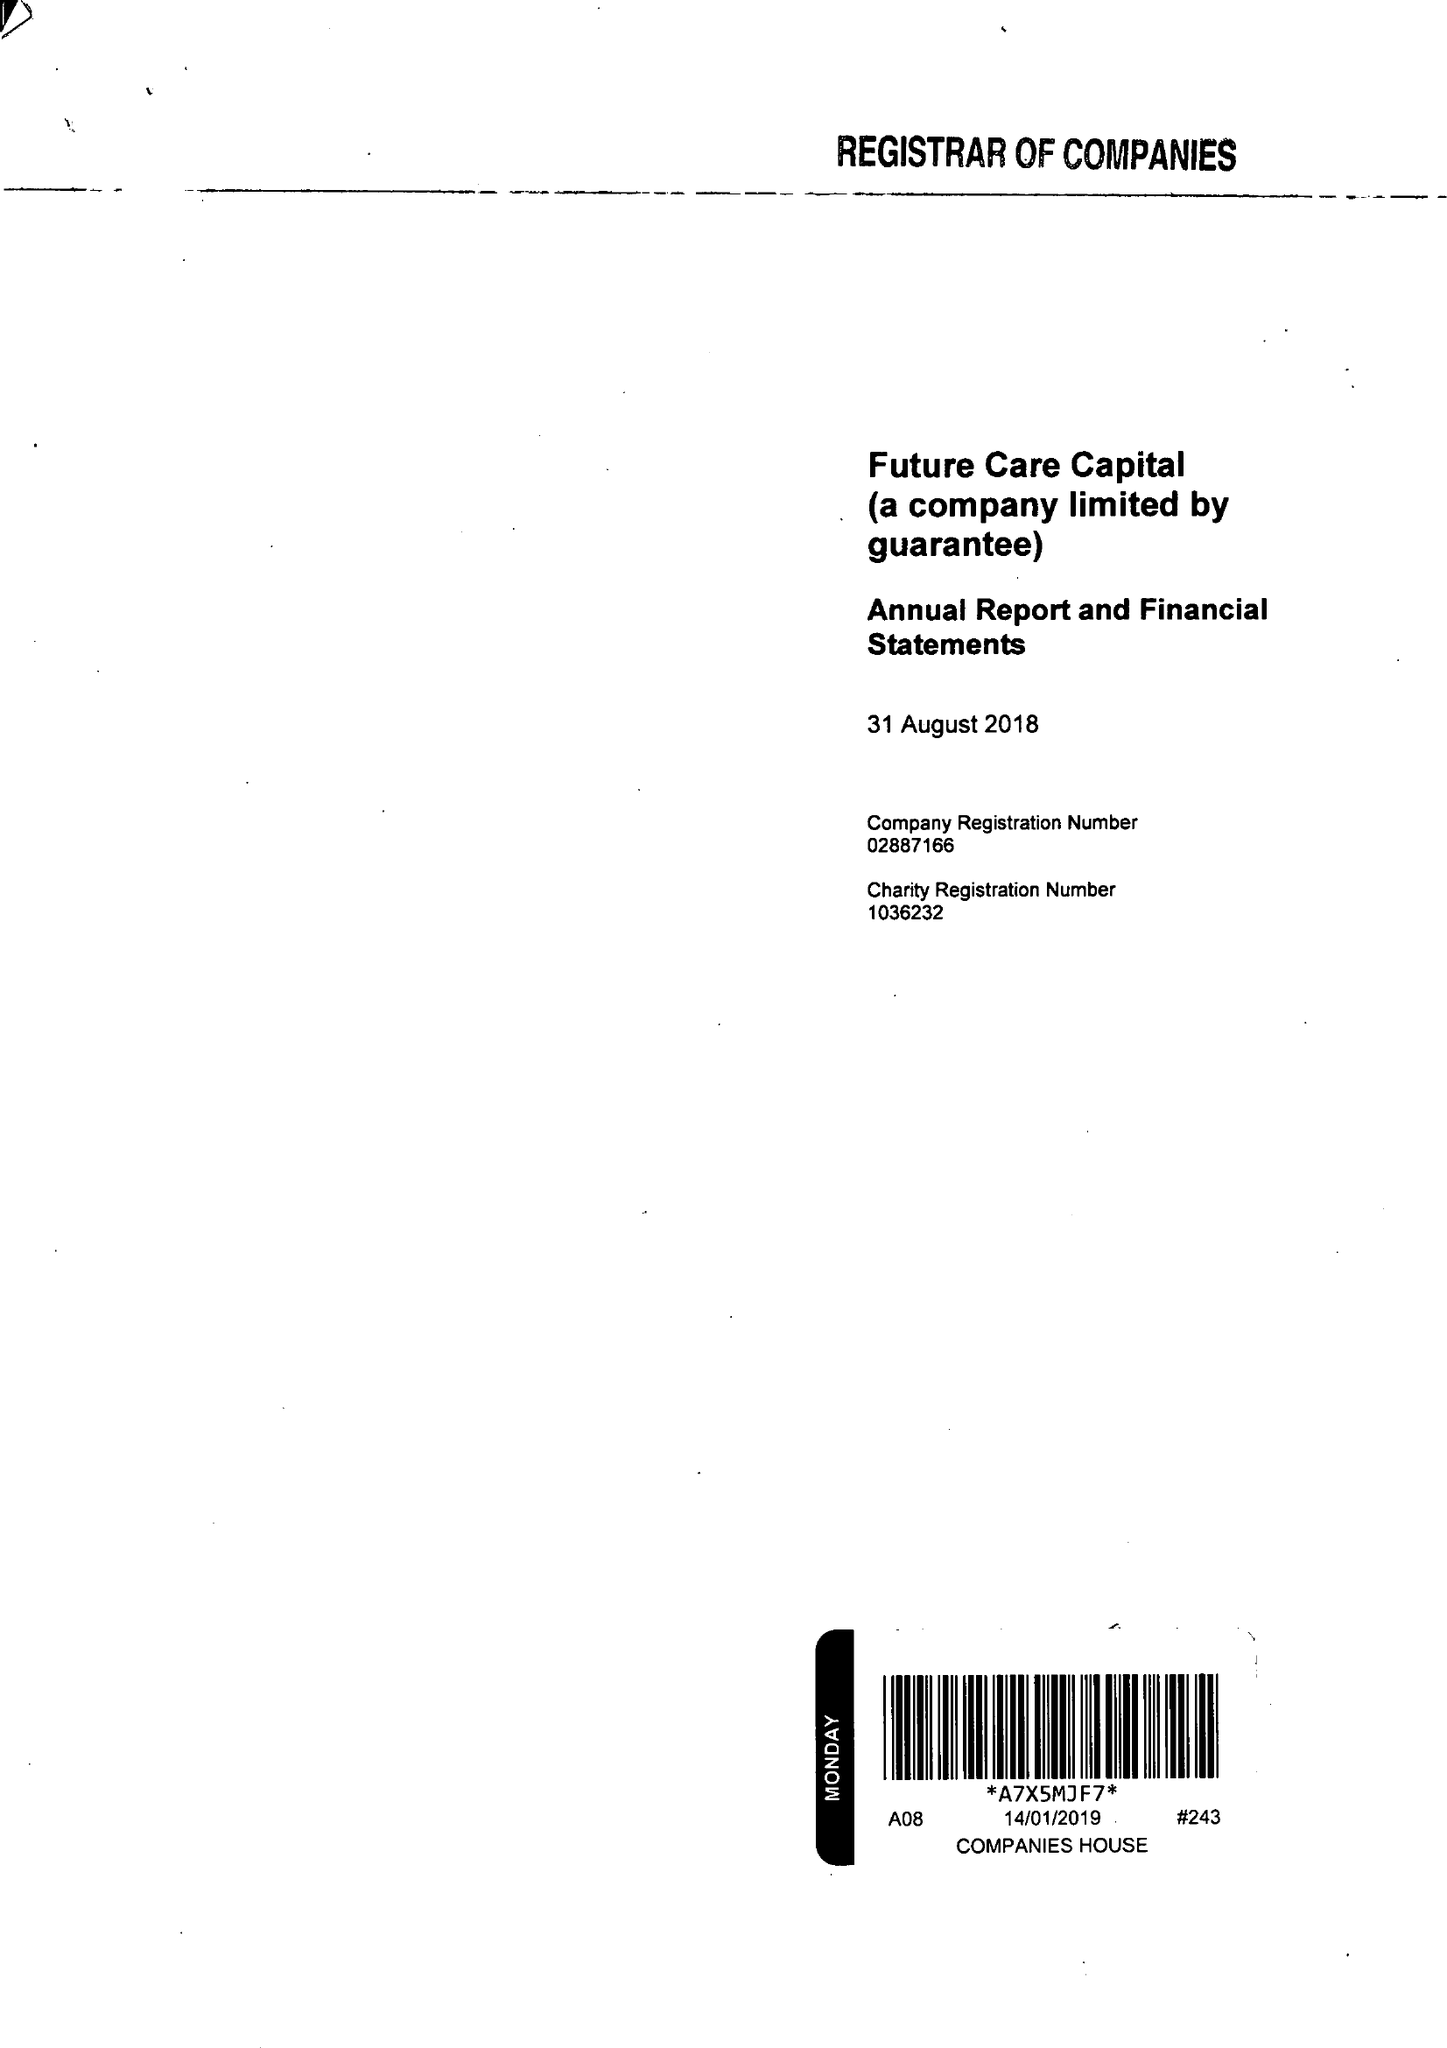What is the value for the spending_annually_in_british_pounds?
Answer the question using a single word or phrase. 1214000.00 